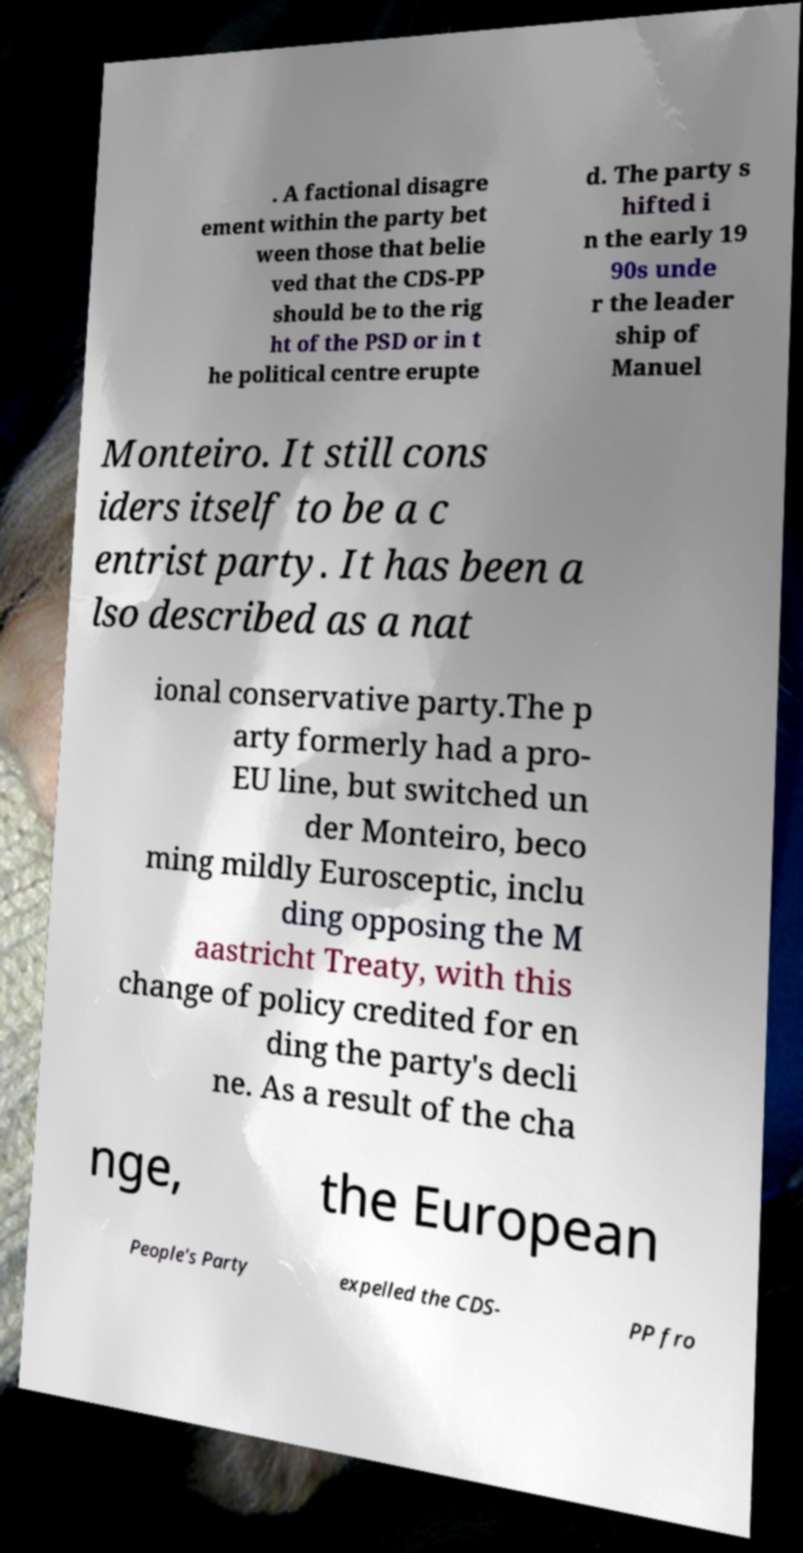Can you accurately transcribe the text from the provided image for me? . A factional disagre ement within the party bet ween those that belie ved that the CDS-PP should be to the rig ht of the PSD or in t he political centre erupte d. The party s hifted i n the early 19 90s unde r the leader ship of Manuel Monteiro. It still cons iders itself to be a c entrist party. It has been a lso described as a nat ional conservative party.The p arty formerly had a pro- EU line, but switched un der Monteiro, beco ming mildly Eurosceptic, inclu ding opposing the M aastricht Treaty, with this change of policy credited for en ding the party's decli ne. As a result of the cha nge, the European People's Party expelled the CDS- PP fro 